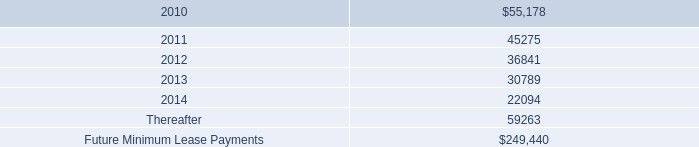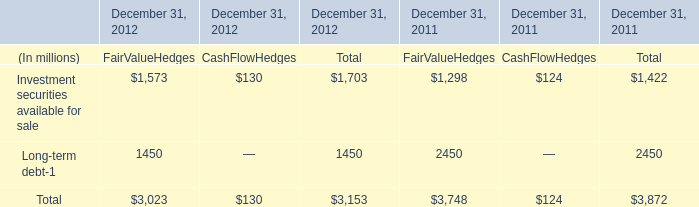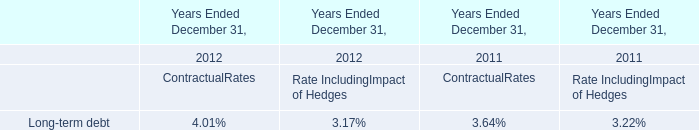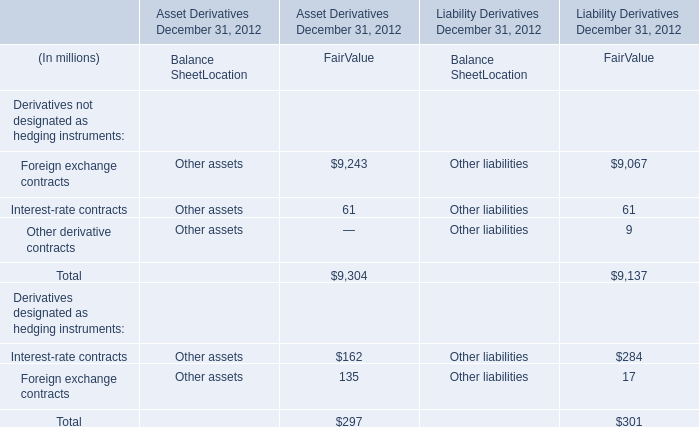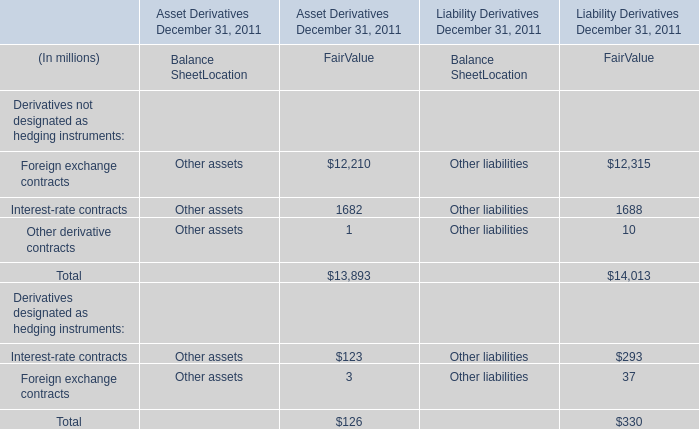In the section with the most Foreign exchange contracts, what is the growth rate of Interest-rate contracts for FairValue? 
Computations: ((1688 - 1682) / 1688)
Answer: 0.00355. 